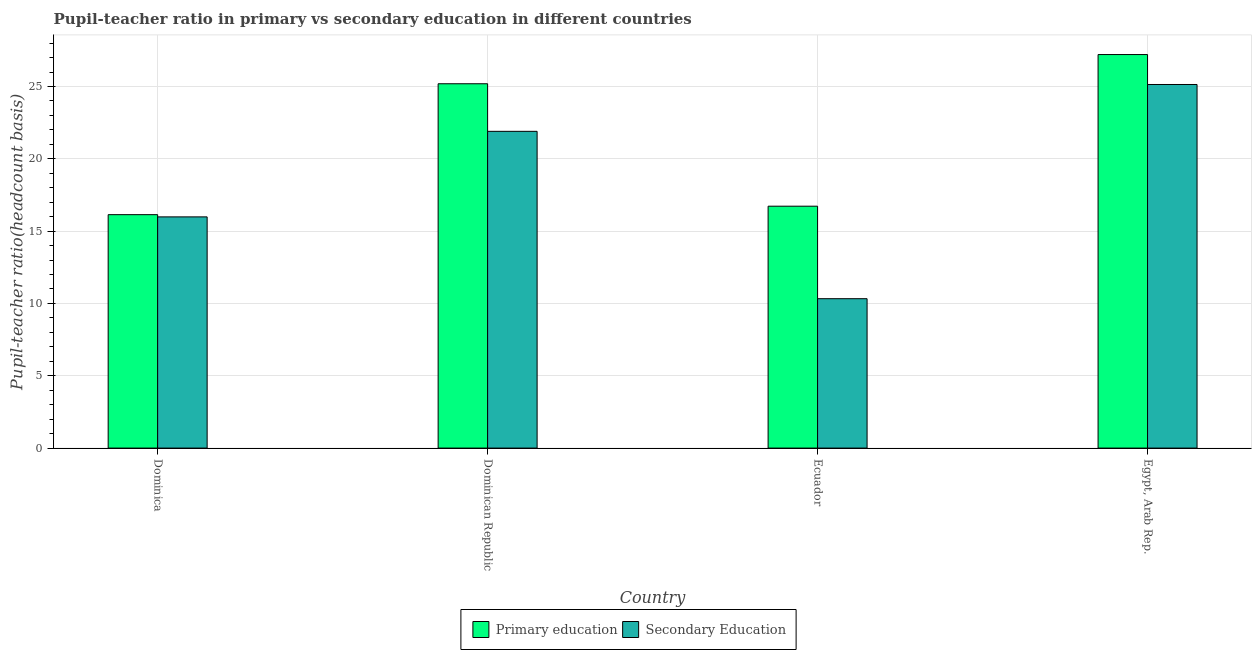Are the number of bars per tick equal to the number of legend labels?
Ensure brevity in your answer.  Yes. Are the number of bars on each tick of the X-axis equal?
Offer a terse response. Yes. What is the label of the 1st group of bars from the left?
Make the answer very short. Dominica. What is the pupil-teacher ratio in primary education in Ecuador?
Offer a very short reply. 16.72. Across all countries, what is the maximum pupil-teacher ratio in primary education?
Offer a very short reply. 27.21. Across all countries, what is the minimum pupil-teacher ratio in primary education?
Your answer should be compact. 16.14. In which country was the pupil teacher ratio on secondary education maximum?
Keep it short and to the point. Egypt, Arab Rep. In which country was the pupil-teacher ratio in primary education minimum?
Your answer should be very brief. Dominica. What is the total pupil-teacher ratio in primary education in the graph?
Your answer should be very brief. 85.26. What is the difference between the pupil-teacher ratio in primary education in Dominica and that in Dominican Republic?
Offer a very short reply. -9.05. What is the difference between the pupil teacher ratio on secondary education in Dominica and the pupil-teacher ratio in primary education in Dominican Republic?
Provide a succinct answer. -9.2. What is the average pupil-teacher ratio in primary education per country?
Keep it short and to the point. 21.32. What is the difference between the pupil-teacher ratio in primary education and pupil teacher ratio on secondary education in Dominican Republic?
Make the answer very short. 3.29. In how many countries, is the pupil-teacher ratio in primary education greater than 22 ?
Offer a very short reply. 2. What is the ratio of the pupil-teacher ratio in primary education in Ecuador to that in Egypt, Arab Rep.?
Make the answer very short. 0.61. What is the difference between the highest and the second highest pupil teacher ratio on secondary education?
Provide a succinct answer. 3.24. What is the difference between the highest and the lowest pupil-teacher ratio in primary education?
Keep it short and to the point. 11.07. In how many countries, is the pupil teacher ratio on secondary education greater than the average pupil teacher ratio on secondary education taken over all countries?
Ensure brevity in your answer.  2. What does the 2nd bar from the left in Ecuador represents?
Keep it short and to the point. Secondary Education. What does the 2nd bar from the right in Ecuador represents?
Ensure brevity in your answer.  Primary education. How many bars are there?
Ensure brevity in your answer.  8. Are all the bars in the graph horizontal?
Provide a succinct answer. No. Are the values on the major ticks of Y-axis written in scientific E-notation?
Your response must be concise. No. Does the graph contain any zero values?
Your response must be concise. No. Does the graph contain grids?
Provide a succinct answer. Yes. How many legend labels are there?
Keep it short and to the point. 2. How are the legend labels stacked?
Your answer should be compact. Horizontal. What is the title of the graph?
Your response must be concise. Pupil-teacher ratio in primary vs secondary education in different countries. Does "IMF concessional" appear as one of the legend labels in the graph?
Make the answer very short. No. What is the label or title of the Y-axis?
Ensure brevity in your answer.  Pupil-teacher ratio(headcount basis). What is the Pupil-teacher ratio(headcount basis) of Primary education in Dominica?
Make the answer very short. 16.14. What is the Pupil-teacher ratio(headcount basis) of Secondary Education in Dominica?
Keep it short and to the point. 15.99. What is the Pupil-teacher ratio(headcount basis) in Primary education in Dominican Republic?
Your answer should be compact. 25.19. What is the Pupil-teacher ratio(headcount basis) of Secondary Education in Dominican Republic?
Keep it short and to the point. 21.9. What is the Pupil-teacher ratio(headcount basis) in Primary education in Ecuador?
Provide a succinct answer. 16.72. What is the Pupil-teacher ratio(headcount basis) of Secondary Education in Ecuador?
Offer a terse response. 10.33. What is the Pupil-teacher ratio(headcount basis) in Primary education in Egypt, Arab Rep.?
Provide a short and direct response. 27.21. What is the Pupil-teacher ratio(headcount basis) in Secondary Education in Egypt, Arab Rep.?
Your answer should be very brief. 25.14. Across all countries, what is the maximum Pupil-teacher ratio(headcount basis) of Primary education?
Provide a succinct answer. 27.21. Across all countries, what is the maximum Pupil-teacher ratio(headcount basis) in Secondary Education?
Ensure brevity in your answer.  25.14. Across all countries, what is the minimum Pupil-teacher ratio(headcount basis) in Primary education?
Your response must be concise. 16.14. Across all countries, what is the minimum Pupil-teacher ratio(headcount basis) of Secondary Education?
Keep it short and to the point. 10.33. What is the total Pupil-teacher ratio(headcount basis) of Primary education in the graph?
Your answer should be compact. 85.26. What is the total Pupil-teacher ratio(headcount basis) in Secondary Education in the graph?
Make the answer very short. 73.35. What is the difference between the Pupil-teacher ratio(headcount basis) in Primary education in Dominica and that in Dominican Republic?
Provide a succinct answer. -9.05. What is the difference between the Pupil-teacher ratio(headcount basis) in Secondary Education in Dominica and that in Dominican Republic?
Give a very brief answer. -5.92. What is the difference between the Pupil-teacher ratio(headcount basis) in Primary education in Dominica and that in Ecuador?
Offer a terse response. -0.59. What is the difference between the Pupil-teacher ratio(headcount basis) of Secondary Education in Dominica and that in Ecuador?
Offer a very short reply. 5.66. What is the difference between the Pupil-teacher ratio(headcount basis) in Primary education in Dominica and that in Egypt, Arab Rep.?
Ensure brevity in your answer.  -11.07. What is the difference between the Pupil-teacher ratio(headcount basis) of Secondary Education in Dominica and that in Egypt, Arab Rep.?
Offer a terse response. -9.15. What is the difference between the Pupil-teacher ratio(headcount basis) in Primary education in Dominican Republic and that in Ecuador?
Your answer should be very brief. 8.47. What is the difference between the Pupil-teacher ratio(headcount basis) of Secondary Education in Dominican Republic and that in Ecuador?
Your response must be concise. 11.57. What is the difference between the Pupil-teacher ratio(headcount basis) in Primary education in Dominican Republic and that in Egypt, Arab Rep.?
Your answer should be very brief. -2.02. What is the difference between the Pupil-teacher ratio(headcount basis) in Secondary Education in Dominican Republic and that in Egypt, Arab Rep.?
Make the answer very short. -3.24. What is the difference between the Pupil-teacher ratio(headcount basis) of Primary education in Ecuador and that in Egypt, Arab Rep.?
Your answer should be very brief. -10.48. What is the difference between the Pupil-teacher ratio(headcount basis) of Secondary Education in Ecuador and that in Egypt, Arab Rep.?
Offer a terse response. -14.81. What is the difference between the Pupil-teacher ratio(headcount basis) in Primary education in Dominica and the Pupil-teacher ratio(headcount basis) in Secondary Education in Dominican Republic?
Make the answer very short. -5.76. What is the difference between the Pupil-teacher ratio(headcount basis) of Primary education in Dominica and the Pupil-teacher ratio(headcount basis) of Secondary Education in Ecuador?
Your response must be concise. 5.81. What is the difference between the Pupil-teacher ratio(headcount basis) in Primary education in Dominica and the Pupil-teacher ratio(headcount basis) in Secondary Education in Egypt, Arab Rep.?
Offer a terse response. -9. What is the difference between the Pupil-teacher ratio(headcount basis) of Primary education in Dominican Republic and the Pupil-teacher ratio(headcount basis) of Secondary Education in Ecuador?
Provide a succinct answer. 14.86. What is the difference between the Pupil-teacher ratio(headcount basis) in Primary education in Dominican Republic and the Pupil-teacher ratio(headcount basis) in Secondary Education in Egypt, Arab Rep.?
Give a very brief answer. 0.05. What is the difference between the Pupil-teacher ratio(headcount basis) of Primary education in Ecuador and the Pupil-teacher ratio(headcount basis) of Secondary Education in Egypt, Arab Rep.?
Keep it short and to the point. -8.41. What is the average Pupil-teacher ratio(headcount basis) of Primary education per country?
Offer a terse response. 21.32. What is the average Pupil-teacher ratio(headcount basis) of Secondary Education per country?
Provide a succinct answer. 18.34. What is the difference between the Pupil-teacher ratio(headcount basis) in Primary education and Pupil-teacher ratio(headcount basis) in Secondary Education in Dominica?
Your answer should be compact. 0.15. What is the difference between the Pupil-teacher ratio(headcount basis) in Primary education and Pupil-teacher ratio(headcount basis) in Secondary Education in Dominican Republic?
Your response must be concise. 3.29. What is the difference between the Pupil-teacher ratio(headcount basis) of Primary education and Pupil-teacher ratio(headcount basis) of Secondary Education in Ecuador?
Ensure brevity in your answer.  6.4. What is the difference between the Pupil-teacher ratio(headcount basis) of Primary education and Pupil-teacher ratio(headcount basis) of Secondary Education in Egypt, Arab Rep.?
Offer a terse response. 2.07. What is the ratio of the Pupil-teacher ratio(headcount basis) of Primary education in Dominica to that in Dominican Republic?
Ensure brevity in your answer.  0.64. What is the ratio of the Pupil-teacher ratio(headcount basis) of Secondary Education in Dominica to that in Dominican Republic?
Your answer should be compact. 0.73. What is the ratio of the Pupil-teacher ratio(headcount basis) in Primary education in Dominica to that in Ecuador?
Ensure brevity in your answer.  0.96. What is the ratio of the Pupil-teacher ratio(headcount basis) in Secondary Education in Dominica to that in Ecuador?
Your answer should be very brief. 1.55. What is the ratio of the Pupil-teacher ratio(headcount basis) in Primary education in Dominica to that in Egypt, Arab Rep.?
Ensure brevity in your answer.  0.59. What is the ratio of the Pupil-teacher ratio(headcount basis) in Secondary Education in Dominica to that in Egypt, Arab Rep.?
Provide a short and direct response. 0.64. What is the ratio of the Pupil-teacher ratio(headcount basis) in Primary education in Dominican Republic to that in Ecuador?
Offer a very short reply. 1.51. What is the ratio of the Pupil-teacher ratio(headcount basis) of Secondary Education in Dominican Republic to that in Ecuador?
Provide a succinct answer. 2.12. What is the ratio of the Pupil-teacher ratio(headcount basis) of Primary education in Dominican Republic to that in Egypt, Arab Rep.?
Your response must be concise. 0.93. What is the ratio of the Pupil-teacher ratio(headcount basis) in Secondary Education in Dominican Republic to that in Egypt, Arab Rep.?
Provide a short and direct response. 0.87. What is the ratio of the Pupil-teacher ratio(headcount basis) in Primary education in Ecuador to that in Egypt, Arab Rep.?
Offer a terse response. 0.61. What is the ratio of the Pupil-teacher ratio(headcount basis) of Secondary Education in Ecuador to that in Egypt, Arab Rep.?
Your answer should be compact. 0.41. What is the difference between the highest and the second highest Pupil-teacher ratio(headcount basis) in Primary education?
Your answer should be very brief. 2.02. What is the difference between the highest and the second highest Pupil-teacher ratio(headcount basis) of Secondary Education?
Your answer should be very brief. 3.24. What is the difference between the highest and the lowest Pupil-teacher ratio(headcount basis) in Primary education?
Your response must be concise. 11.07. What is the difference between the highest and the lowest Pupil-teacher ratio(headcount basis) of Secondary Education?
Keep it short and to the point. 14.81. 